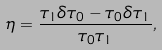<formula> <loc_0><loc_0><loc_500><loc_500>\eta = \frac { \tau _ { 1 } \delta \tau _ { 0 } - \tau _ { 0 } \delta \tau _ { 1 } } { \tau _ { 0 } \tau _ { 1 } } ,</formula> 